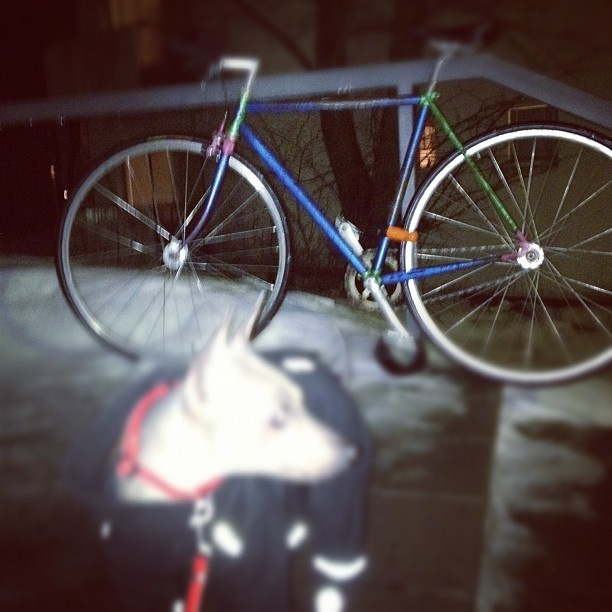Describe the objects in this image and their specific colors. I can see bicycle in black, gray, and darkgray tones, dog in black, white, gray, and darkgray tones, and bicycle in black, gray, and white tones in this image. 